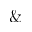<formula> <loc_0><loc_0><loc_500><loc_500>\&</formula> 